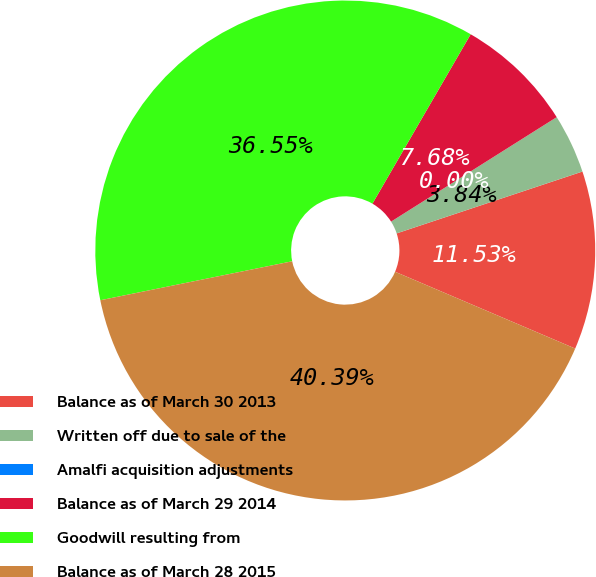<chart> <loc_0><loc_0><loc_500><loc_500><pie_chart><fcel>Balance as of March 30 2013<fcel>Written off due to sale of the<fcel>Amalfi acquisition adjustments<fcel>Balance as of March 29 2014<fcel>Goodwill resulting from<fcel>Balance as of March 28 2015<nl><fcel>11.53%<fcel>3.84%<fcel>0.0%<fcel>7.68%<fcel>36.55%<fcel>40.39%<nl></chart> 